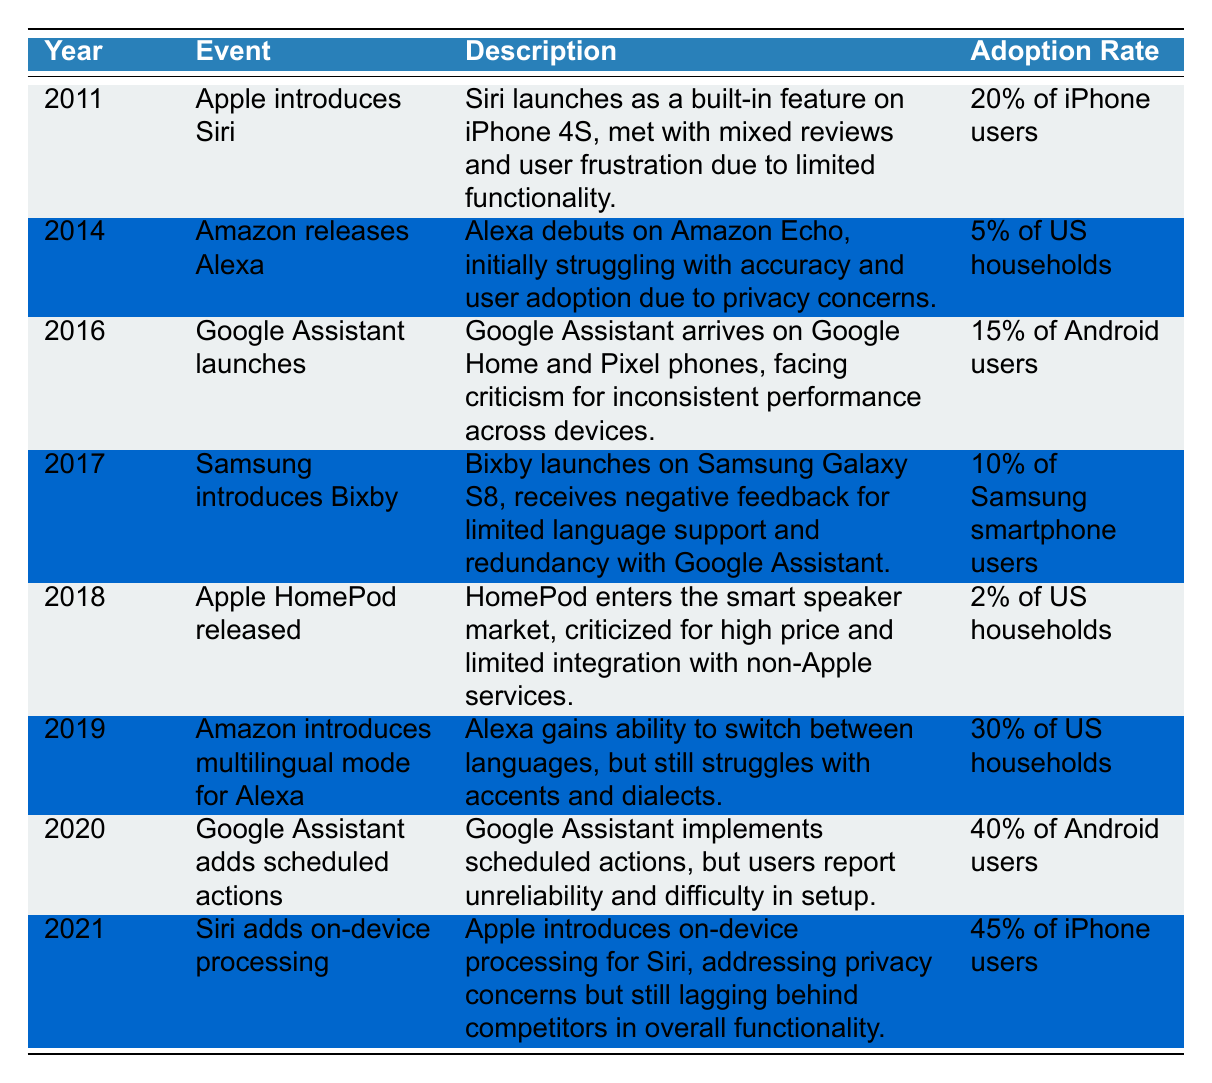What year did Apple introduce Siri? The table lists the events chronologically, and the first entry shows that Apple introduced Siri in the year 2011.
Answer: 2011 What was the adoption rate of Alexa when it was released? According to the table, when Alexa was released in 2014, its adoption rate was noted as 5% of US households.
Answer: 5% of US households Which voice assistant had the highest adoption rate in 2021? The table shows the adoption rates for Siri (45%), Alexa (30%), Google Assistant (40%), and Bixby (10%) in 2021. Among these, Siri has the highest adoption rate at 45%.
Answer: Siri Did the adoption rate of Google Assistant increase from 2016 to 2020? In 2016, the adoption rate for Google Assistant was 15% of Android users, while in 2020 it increased to 40%. So, yes, the adoption rate increased during this period.
Answer: Yes What was the average adoption rate of voice assistants from 2014 to 2021? The adoption rates in this range are 5% (2014), 15% (2016), 10% (2017), 2% (2018), 30% (2019), 40% (2020), and 45% (2021). Adding these rates gives 5 + 15 + 10 + 2 + 30 + 40 + 45 = 147. There are 7 data points, so the average adoption rate is 147 / 7 = 21. Thereby, the average adoption rate is 21%.
Answer: 21% Which voice assistant faced criticism for inconsistent performance across devices? The table indicates that Google Assistant faced criticism for inconsistent performance when it launched in 2016.
Answer: Google Assistant What year did Amazon introduce a multilingual mode for Alexa? According to the timeline, Amazon introduced the multilingual mode for Alexa in 2019.
Answer: 2019 Was the adoption rate of Siri higher than that of Bixby in their respective release years? Siri was released in 2011 with a 20% adoption rate, while Bixby launched in 2017 with a 10% adoption rate. Since 20% is greater than 10%, the adoption rate of Siri was indeed higher.
Answer: Yes Did the adoption rate of voice assistants show an overall upward trend from 2014 to 2021? Analyzing the data, the adoption rates over the years are as follows: 5% (2014), 15% (2016), 10% (2017), 2% (2018), 30% (2019), 40% (2020), and 45% (2021). Although there are fluctuations, the overall trend from 2014 to 2021 shows an increase, especially in the later years.
Answer: Yes 